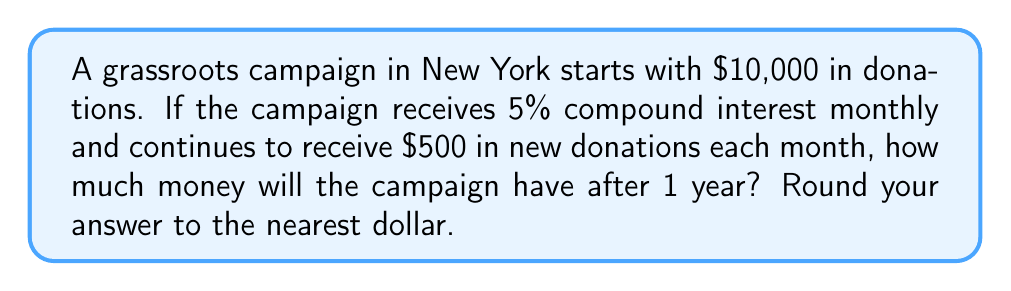Show me your answer to this math problem. Let's approach this step-by-step using the compound interest formula with regular contributions:

1) The formula for compound interest with regular contributions is:
   $$A = P(1 + r)^n + c[\frac{(1 + r)^n - 1}{r}]$$
   Where:
   $A$ = final amount
   $P$ = principal (initial investment)
   $r$ = interest rate per compounding period
   $n$ = number of compounding periods
   $c$ = regular contribution amount

2) In this case:
   $P = 10000$ (initial donation)
   $r = 0.05/12 = 0.004167$ (5% annual rate converted to monthly)
   $n = 12$ (12 months in a year)
   $c = 500$ (monthly donation)

3) Let's substitute these values into the formula:
   $$A = 10000(1 + 0.004167)^{12} + 500[\frac{(1 + 0.004167)^{12} - 1}{0.004167}]$$

4) Simplify the first part:
   $10000(1.004167)^{12} = 10512.68$

5) Simplify the second part:
   $500[\frac{1.051271 - 1}{0.004167}] = 6148.97$

6) Add the two parts:
   $10512.68 + 6148.97 = 16661.65$

7) Rounding to the nearest dollar:
   $16662$
Answer: $16,662 